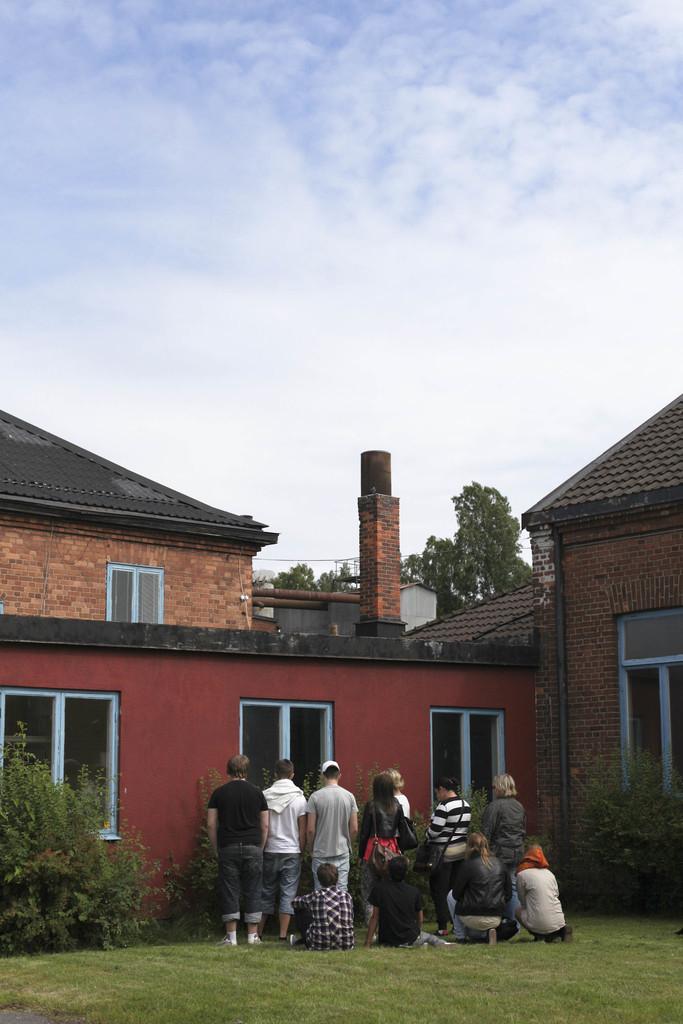In one or two sentences, can you explain what this image depicts? In this image I can see at the bottom there are people standing, on the left side there are trees. In the middle there is a house, at the top it is the cloudy sky. 